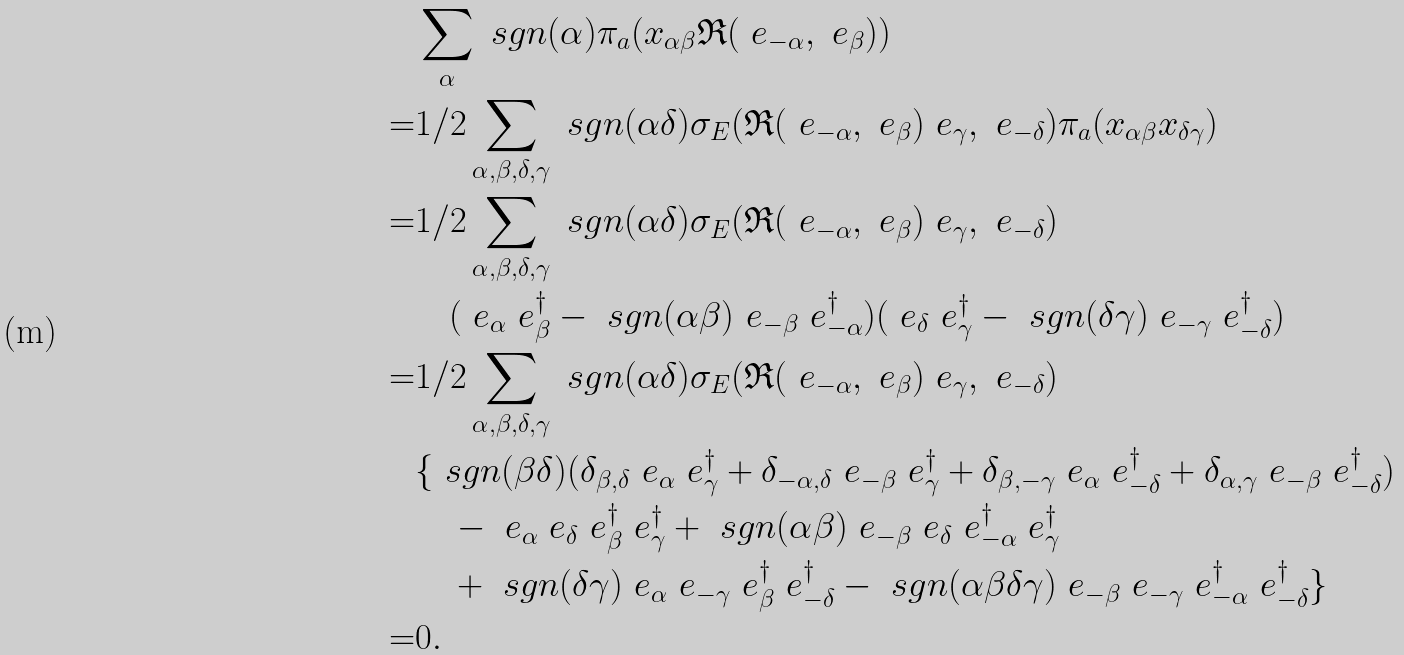<formula> <loc_0><loc_0><loc_500><loc_500>& \sum _ { \alpha } \ s g n ( \alpha ) \pi _ { a } ( x _ { \alpha \beta } \mathfrak { R } ( \ e _ { - \alpha } , \ e _ { \beta } ) ) \\ = & 1 / 2 \sum _ { \alpha , \beta , \delta , \gamma } \ s g n ( \alpha \delta ) \sigma _ { E } ( \mathfrak { R } ( \ e _ { - \alpha } , \ e _ { \beta } ) \ e _ { \gamma } , \ e _ { - \delta } ) \pi _ { a } ( x _ { \alpha \beta } x _ { \delta \gamma } ) \\ = & 1 / 2 \sum _ { \alpha , \beta , \delta , \gamma } \ s g n ( \alpha \delta ) \sigma _ { E } ( \mathfrak { R } ( \ e _ { - \alpha } , \ e _ { \beta } ) \ e _ { \gamma } , \ e _ { - \delta } ) \\ & \quad ( \ e _ { \alpha } \ e _ { \beta } ^ { \dagger } - \ s g n ( \alpha \beta ) \ e _ { - \beta } \ e _ { - \alpha } ^ { \dagger } ) ( \ e _ { \delta } \ e _ { \gamma } ^ { \dagger } - \ s g n ( \delta \gamma ) \ e _ { - \gamma } \ e _ { - \delta } ^ { \dagger } ) \\ = & 1 / 2 \sum _ { \alpha , \beta , \delta , \gamma } \ s g n ( \alpha \delta ) \sigma _ { E } ( \mathfrak { R } ( \ e _ { - \alpha } , \ e _ { \beta } ) \ e _ { \gamma } , \ e _ { - \delta } ) \\ & \{ \ s g n ( \beta \delta ) ( \delta _ { \beta , \delta } \ e _ { \alpha } \ e _ { \gamma } ^ { \dagger } + \delta _ { - \alpha , \delta } \ e _ { - \beta } \ e _ { \gamma } ^ { \dagger } + \delta _ { \beta , - \gamma } \ e _ { \alpha } \ e _ { - \delta } ^ { \dagger } + \delta _ { \alpha , \gamma } \ e _ { - \beta } \ e _ { - \delta } ^ { \dagger } ) \\ & \quad - \ e _ { \alpha } \ e _ { \delta } \ e _ { \beta } ^ { \dagger } \ e _ { \gamma } ^ { \dagger } + \ s g n ( \alpha \beta ) \ e _ { - \beta } \ e _ { \delta } \ e _ { - \alpha } ^ { \dagger } \ e _ { \gamma } ^ { \dagger } \\ & \quad + \ s g n ( \delta \gamma ) \ e _ { \alpha } \ e _ { - \gamma } \ e _ { \beta } ^ { \dagger } \ e _ { - \delta } ^ { \dagger } - \ s g n ( \alpha \beta \delta \gamma ) \ e _ { - \beta } \ e _ { - \gamma } \ e _ { - \alpha } ^ { \dagger } \ e _ { - \delta } ^ { \dagger } \} \\ = & 0 .</formula> 